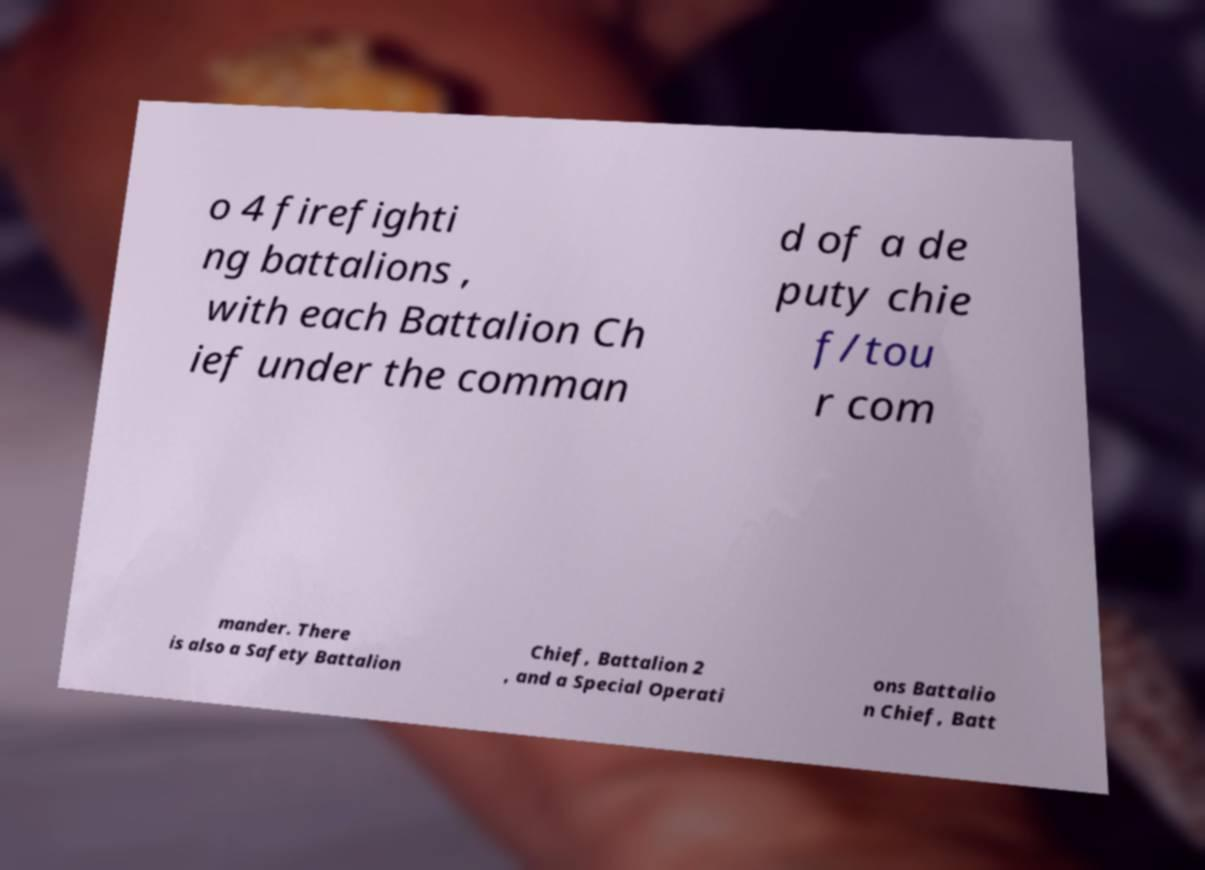Could you extract and type out the text from this image? o 4 firefighti ng battalions , with each Battalion Ch ief under the comman d of a de puty chie f/tou r com mander. There is also a Safety Battalion Chief, Battalion 2 , and a Special Operati ons Battalio n Chief, Batt 